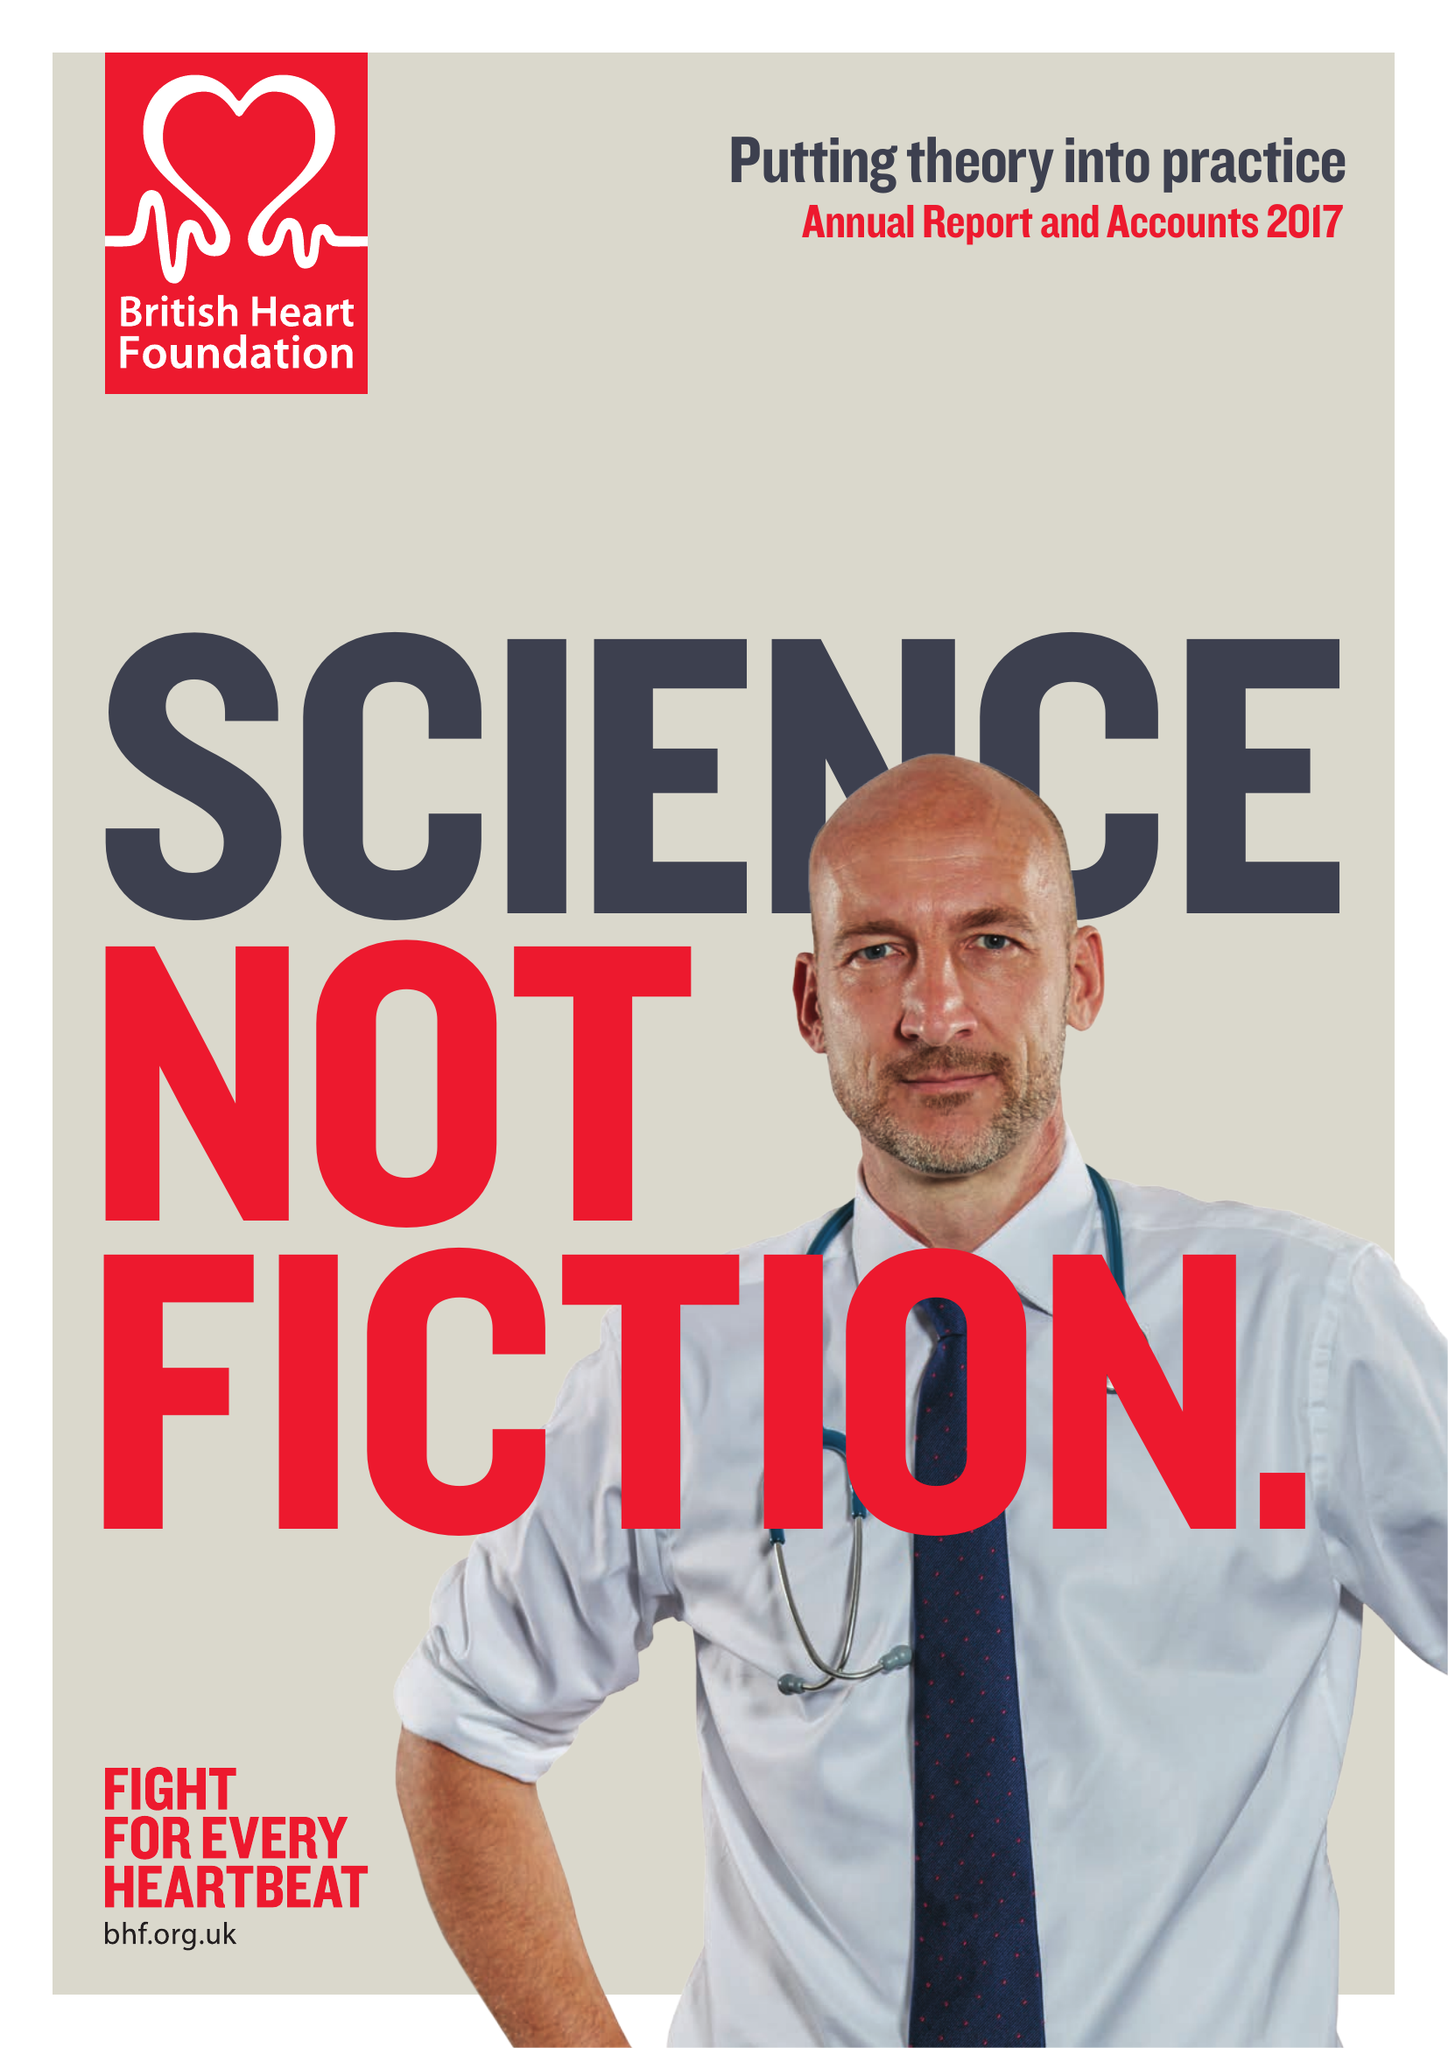What is the value for the address__postcode?
Answer the question using a single word or phrase. NW1 7AW 